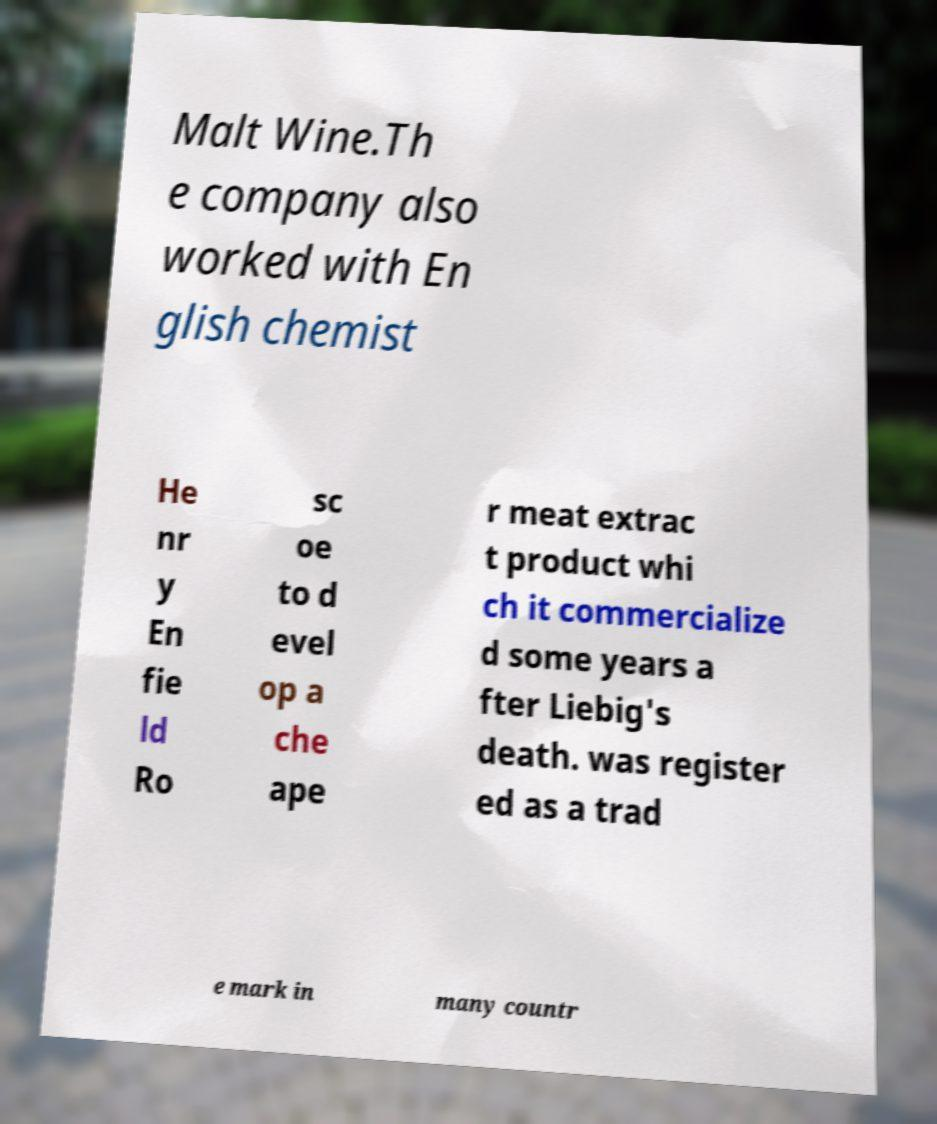For documentation purposes, I need the text within this image transcribed. Could you provide that? Malt Wine.Th e company also worked with En glish chemist He nr y En fie ld Ro sc oe to d evel op a che ape r meat extrac t product whi ch it commercialize d some years a fter Liebig's death. was register ed as a trad e mark in many countr 